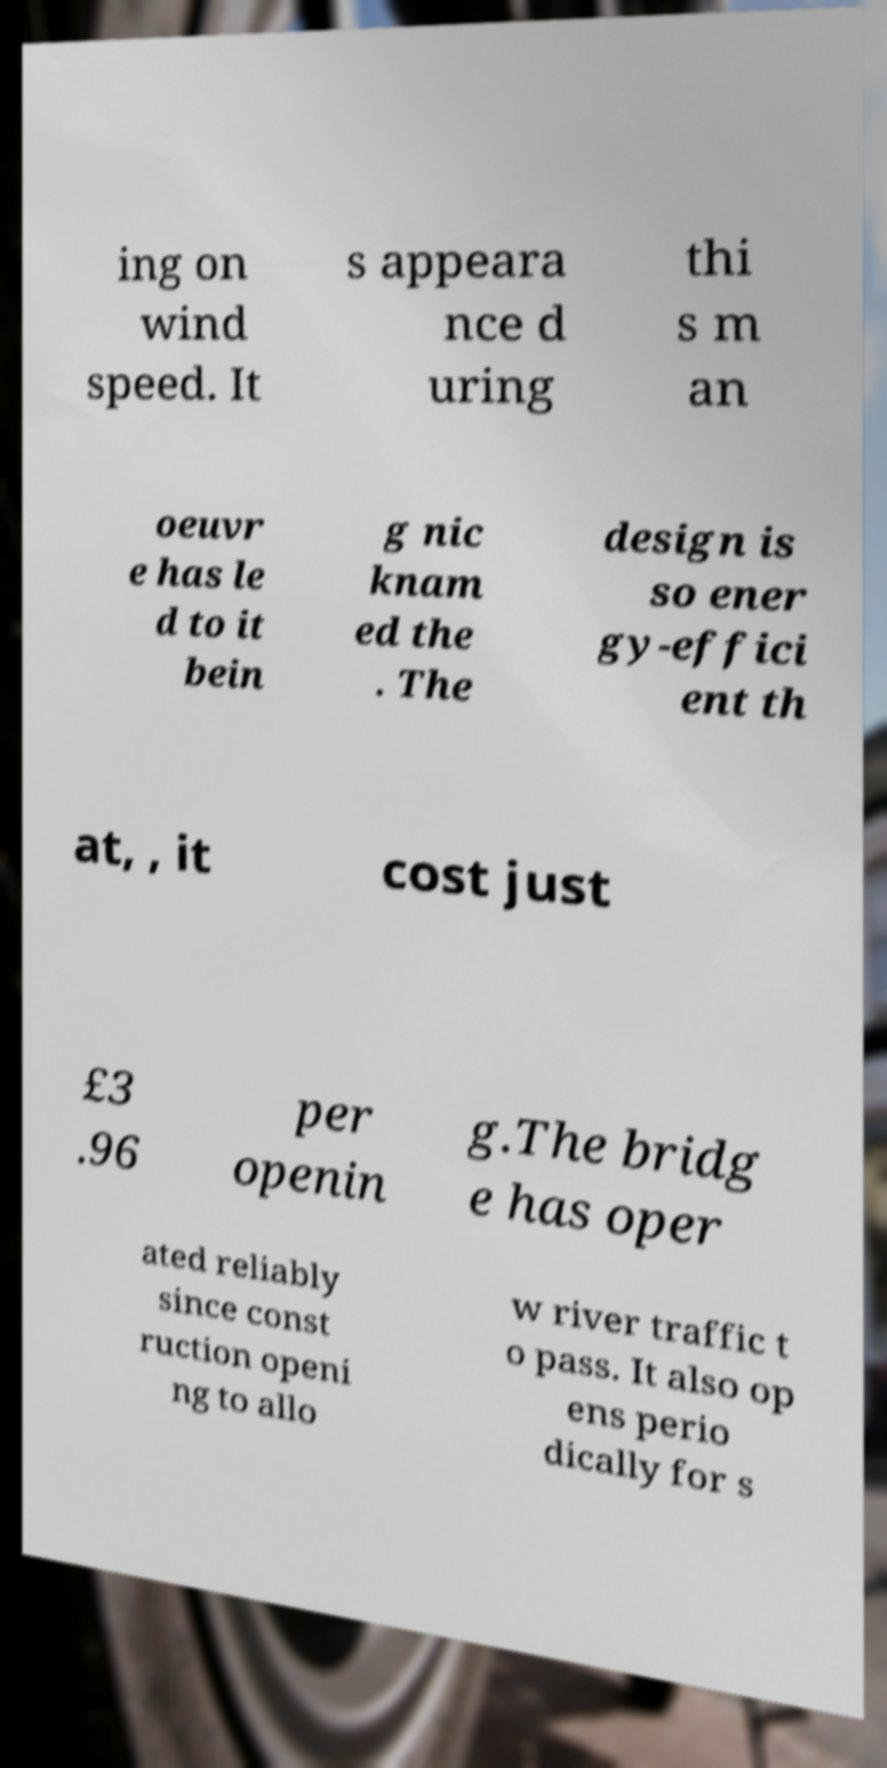I need the written content from this picture converted into text. Can you do that? ing on wind speed. It s appeara nce d uring thi s m an oeuvr e has le d to it bein g nic knam ed the . The design is so ener gy-effici ent th at, , it cost just £3 .96 per openin g.The bridg e has oper ated reliably since const ruction openi ng to allo w river traffic t o pass. It also op ens perio dically for s 